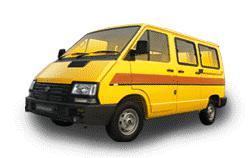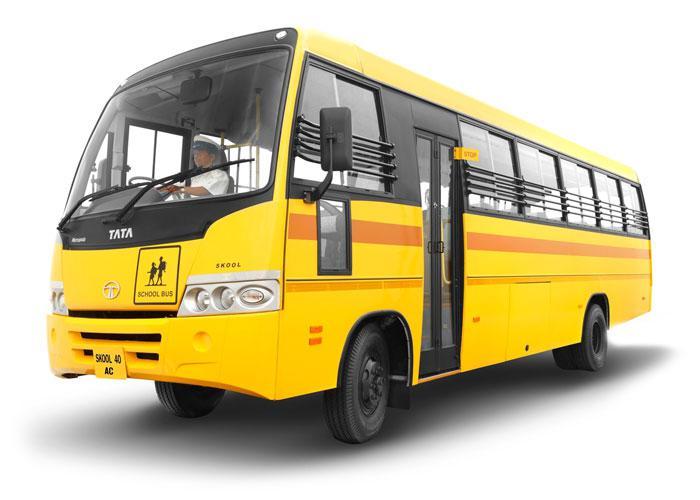The first image is the image on the left, the second image is the image on the right. Given the left and right images, does the statement "Both yellow buses are facing the same direction." hold true? Answer yes or no. Yes. The first image is the image on the left, the second image is the image on the right. Examine the images to the left and right. Is the description "The vehicles are facing in the same direction." accurate? Answer yes or no. Yes. 